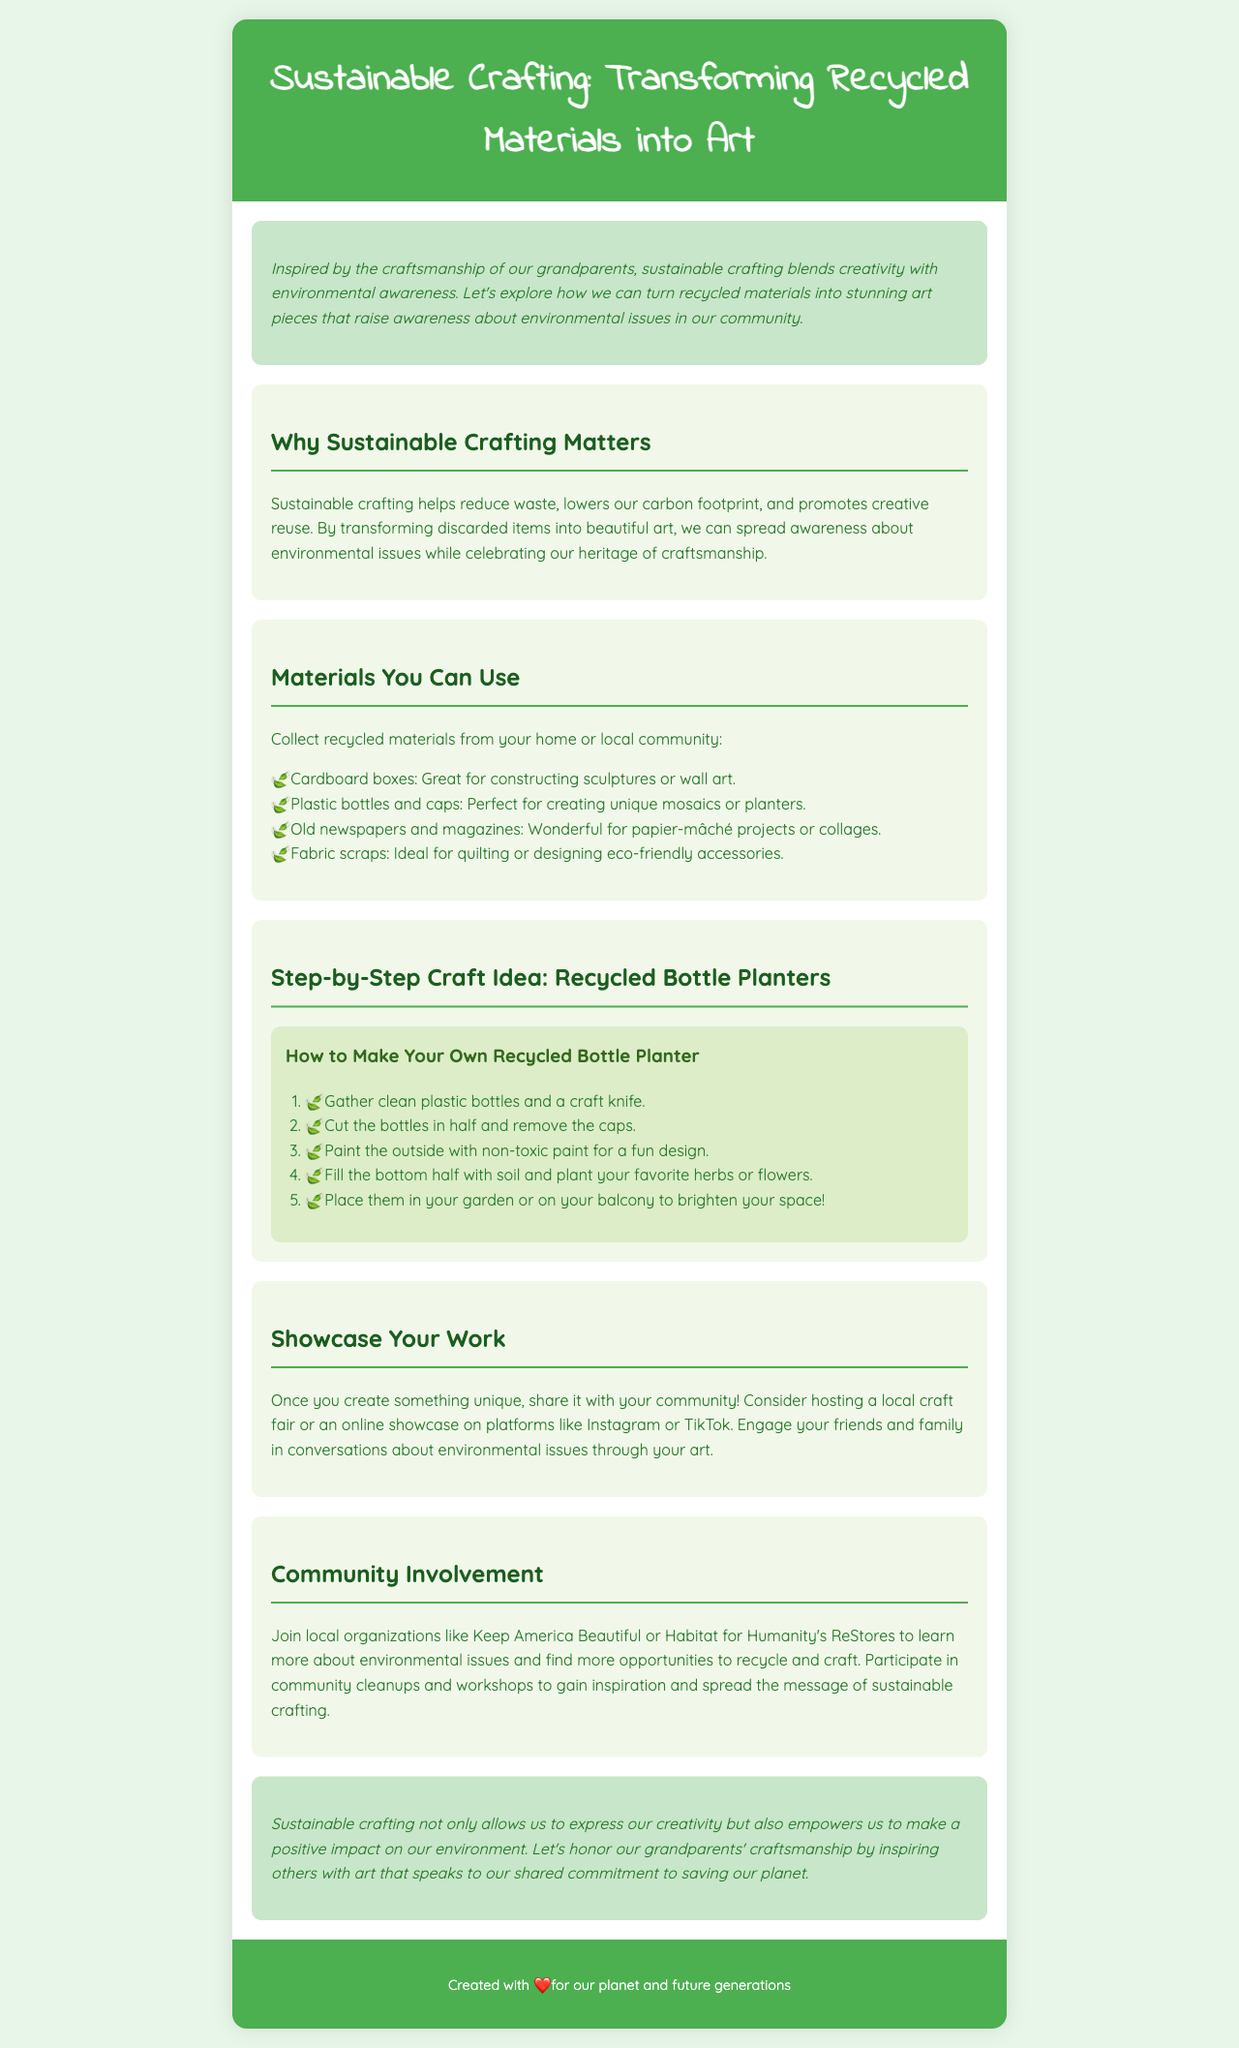What is the title of the newsletter? The title is clearly stated in the header of the document.
Answer: Sustainable Crafting: Transforming Recycled Materials into Art What materials can be collected for crafting? The document lists the materials in a section, including cardboard boxes, plastic bottles, old newspapers, and fabric scraps.
Answer: Cardboard boxes, plastic bottles and caps, old newspapers and magazines, fabric scraps What is the first step in making recycled bottle planters? The steps for making recycled bottle planters are outlined in an ordered list in the document.
Answer: Gather clean plastic bottles and a craft knife What organization can you join for community involvement? The document mentions local organizations engaged in environmental issues; one is specifically named in this section.
Answer: Keep America Beautiful What is one way to showcase your crafted work? The document suggests a method for sharing creations with the community.
Answer: Hosting a local craft fair Why is sustainable crafting important? The reasoning is provided in the section discussing the significance of sustainable crafting.
Answer: Reduces waste and lowers carbon footprint What color scheme does the newsletter use? The colors for the body and header sections are mentioned in the style section.
Answer: Green and white How does sustainable crafting connect to heritage? The introduction emphasizes a particular connection between crafting and family history.
Answer: It celebrates our heritage of craftsmanship 